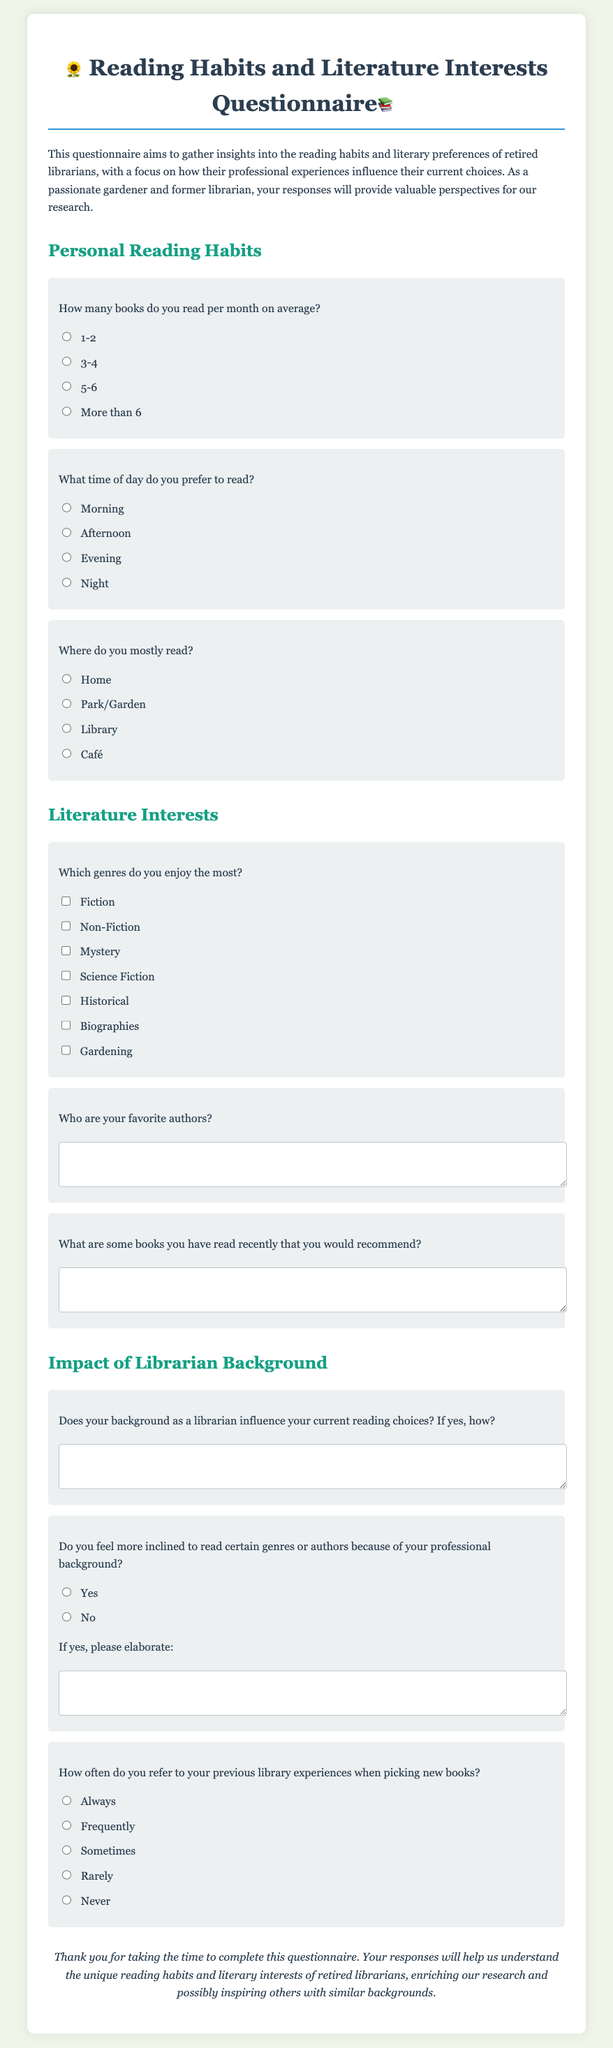How many books does the average respondent read per month? The document presents multiple-choice options for the number of books read per month, which include 1-2, 3-4, 5-6, and more than 6.
Answer: 1-2, 3-4, 5-6, More than 6 What is the main purpose of this questionnaire? The questionnaire aims to gather insights into the reading habits and literary preferences of retired librarians.
Answer: Gather insights into reading habits and literary preferences What genres are listed as favorite options in the questionnaire? The document contains checkboxes for various genres, including Fiction, Non-Fiction, Mystery, Science Fiction, Historical, Biographies, and Gardening.
Answer: Fiction, Non-Fiction, Mystery, Science Fiction, Historical, Biographies, Gardening What is the concluding statement of the document? The conclusion of the questionnaire expresses gratitude towards participants and highlights the importance of their responses for research.
Answer: Thank you for taking the time to complete this questionnaire How often do respondents refer to previous library experiences when selecting new books? Options provided in the document range from Always to Never, indicating varying frequency of reference to past experiences.
Answer: Always, Frequently, Sometimes, Rarely, Never 